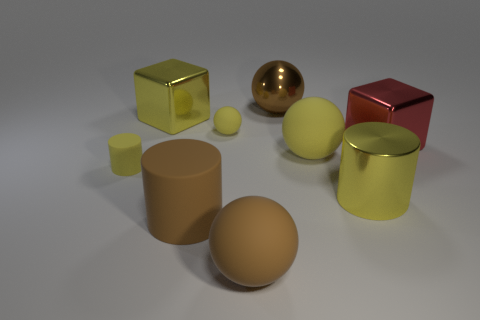Is the size of the red shiny block the same as the yellow matte object left of the tiny rubber ball?
Your answer should be compact. No. How many metallic objects are either yellow cylinders or big blocks?
Your response must be concise. 3. What number of other large rubber objects are the same shape as the red object?
Offer a very short reply. 0. There is a block that is the same color as the tiny rubber cylinder; what is its material?
Keep it short and to the point. Metal. There is a metallic thing in front of the large red object; does it have the same size as the metallic cube on the right side of the metallic sphere?
Your answer should be compact. Yes. The tiny matte object that is right of the big rubber cylinder has what shape?
Your answer should be compact. Sphere. There is another tiny thing that is the same shape as the brown shiny thing; what is it made of?
Offer a very short reply. Rubber. There is a yellow rubber object that is behind the red metal block; does it have the same size as the yellow cube?
Offer a very short reply. No. What number of small objects are to the right of the large rubber cylinder?
Provide a succinct answer. 1. Is the number of metal things left of the large metallic cylinder less than the number of big things that are right of the yellow cube?
Make the answer very short. Yes. 